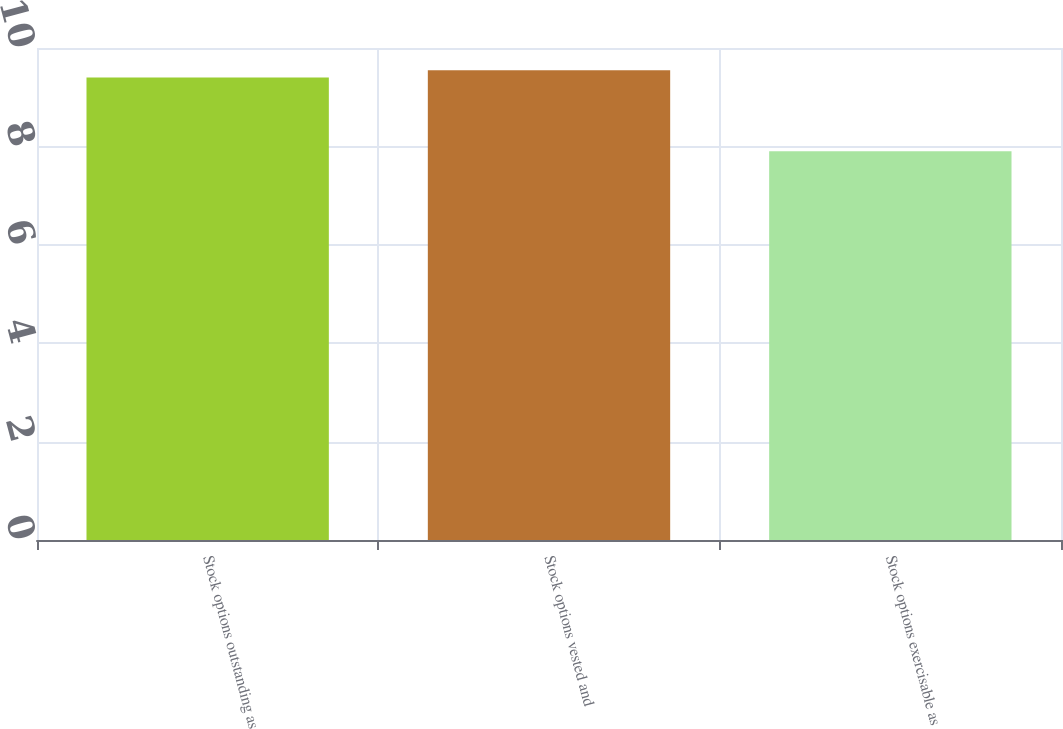<chart> <loc_0><loc_0><loc_500><loc_500><bar_chart><fcel>Stock options outstanding as<fcel>Stock options vested and<fcel>Stock options exercisable as<nl><fcel>9.4<fcel>9.55<fcel>7.9<nl></chart> 